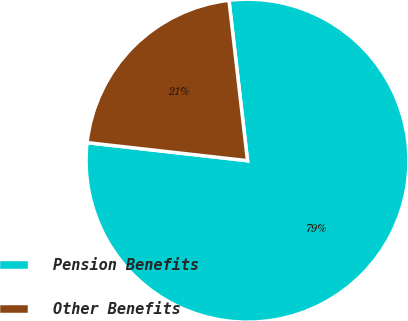<chart> <loc_0><loc_0><loc_500><loc_500><pie_chart><fcel>Pension Benefits<fcel>Other Benefits<nl><fcel>78.62%<fcel>21.38%<nl></chart> 